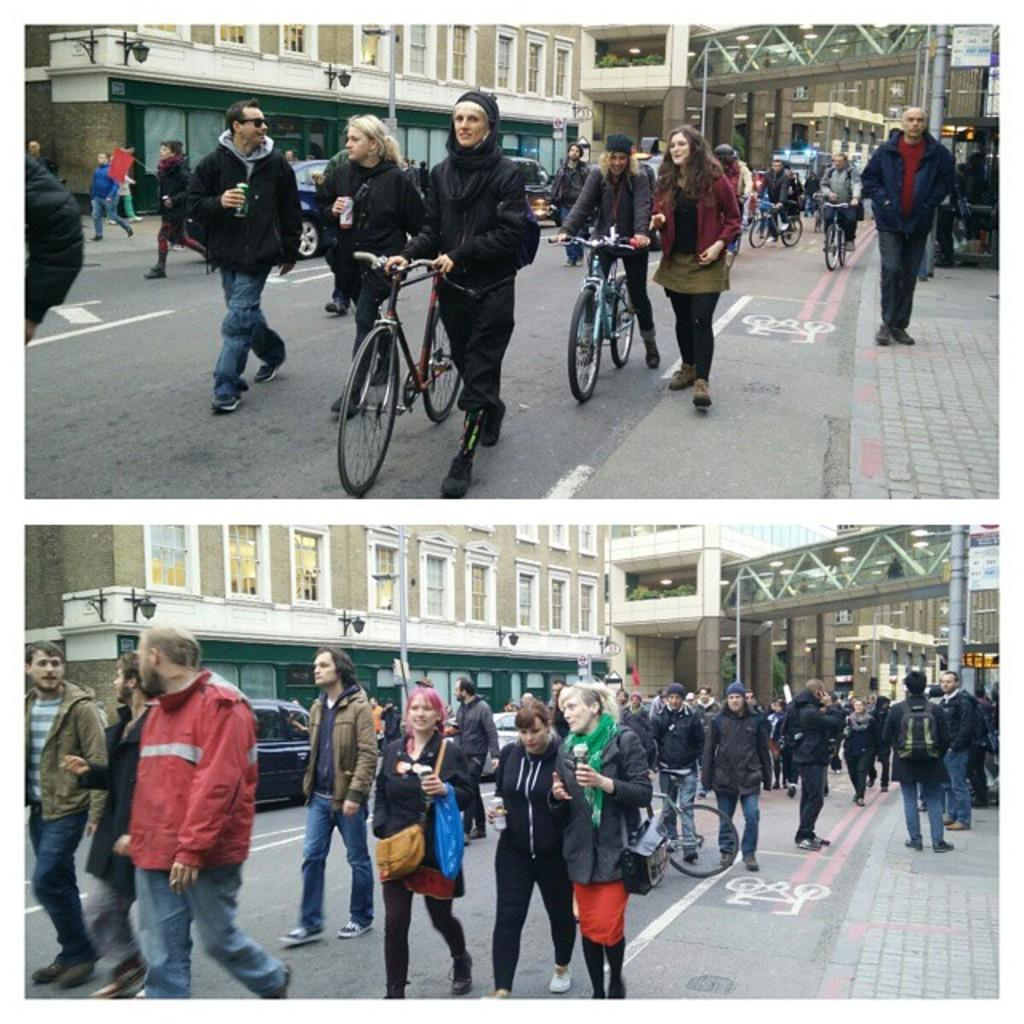What are the people in the image doing? There are people walking in the image. What else can be seen in the image besides people walking? Two bicycles are present in the image. Are there any other groups of people in the image? Yes, there is a crowd walking in another part of the image. What can be seen in the background of the image? There is a building in the background of the image. What type of bubble can be seen floating in the image? There is no bubble present in the image. How does the vegetable increase in size in the image? There is no vegetable present in the image, so it cannot increase in size. 